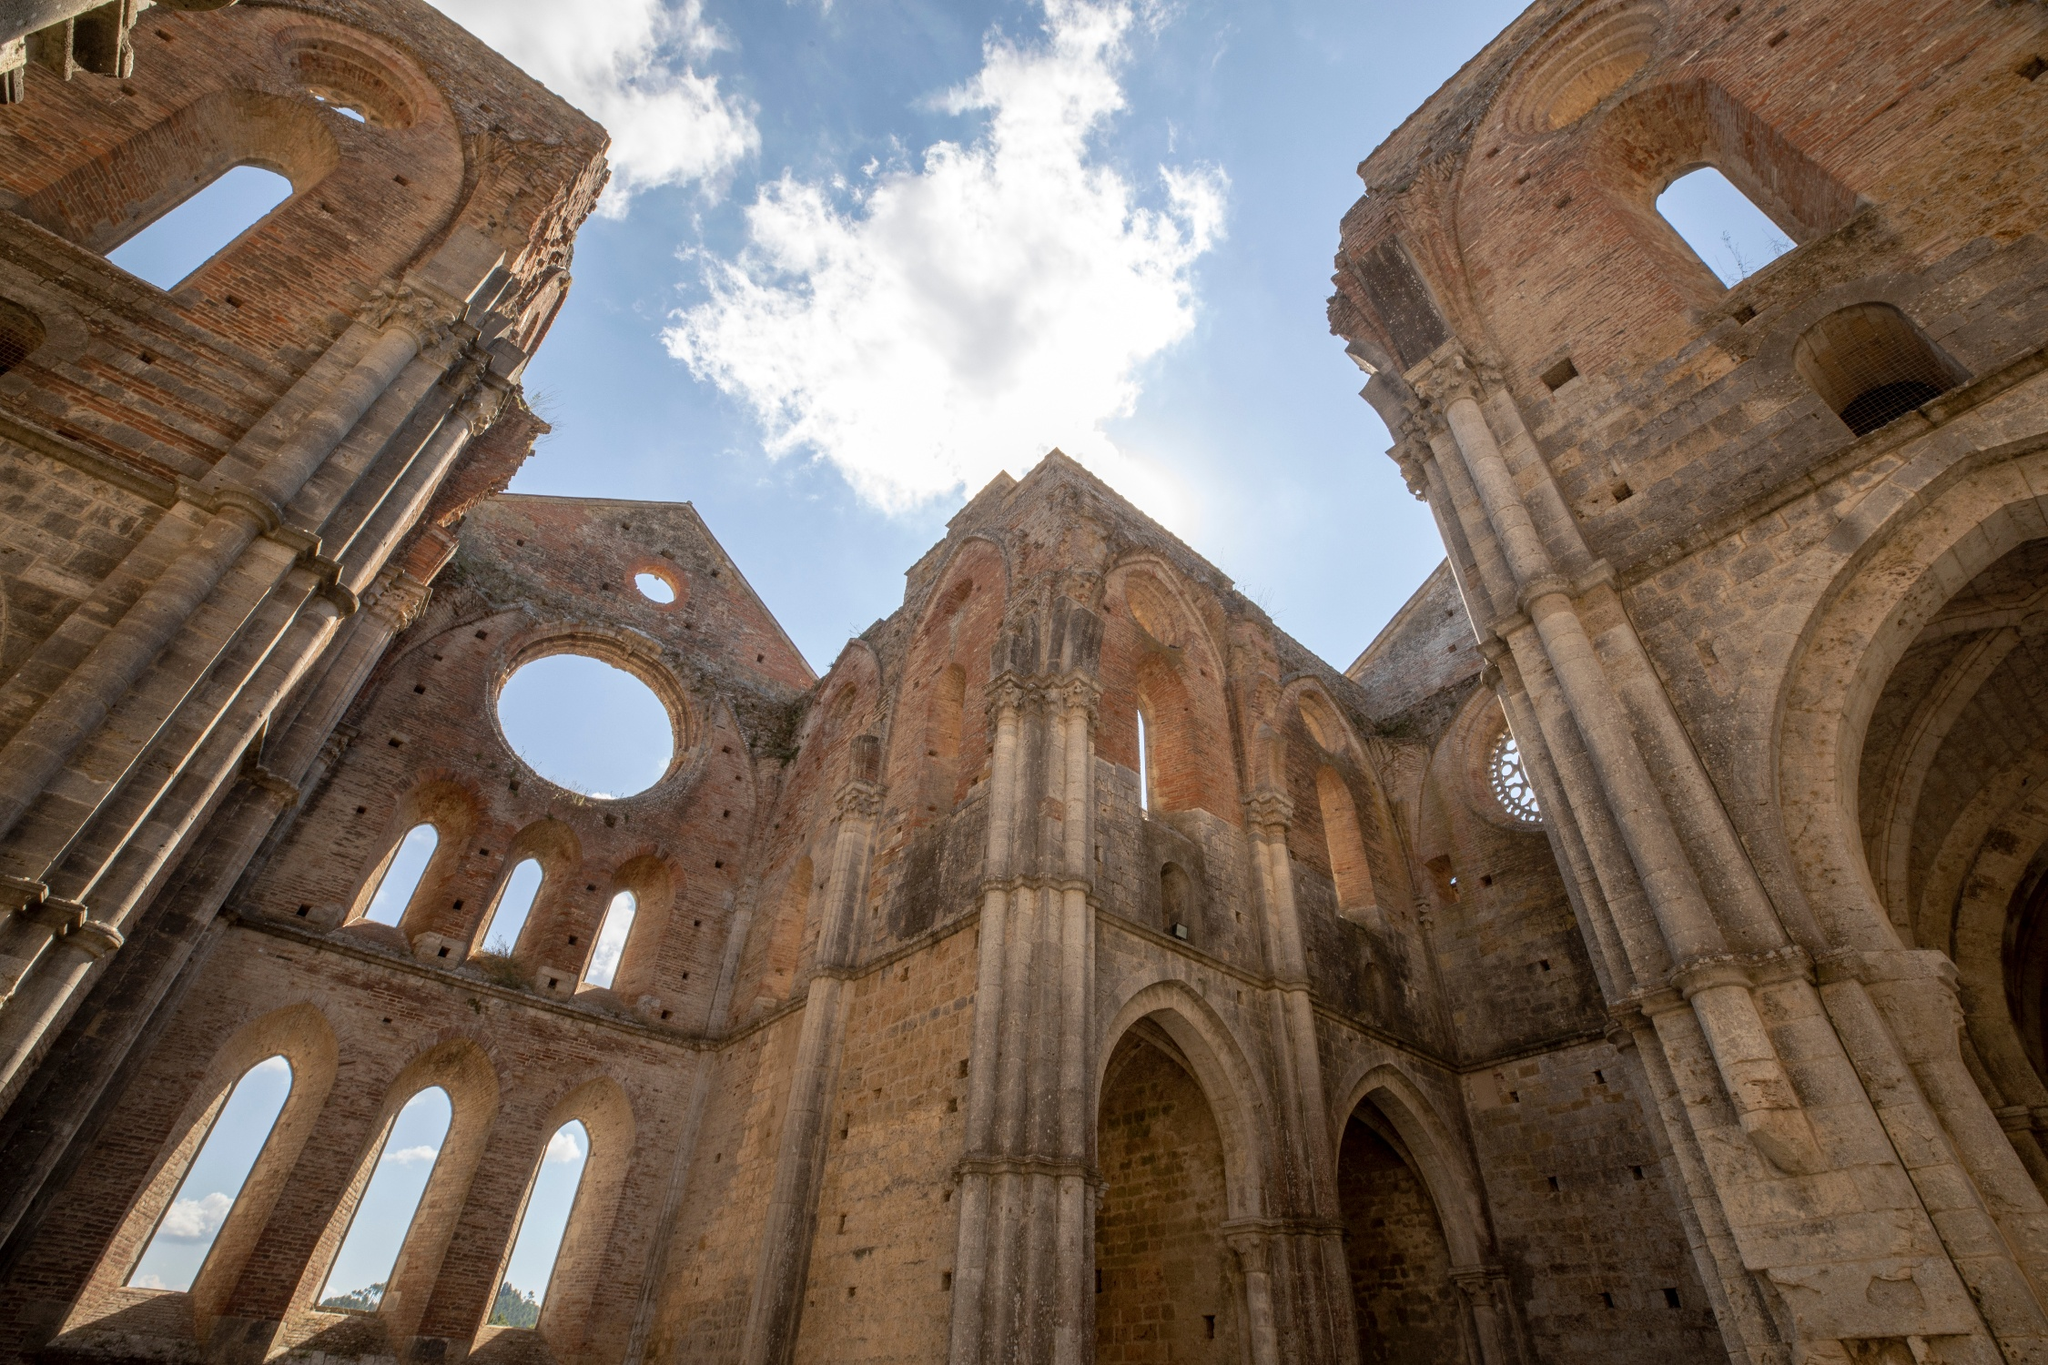Explain the visual content of the image in great detail. The image presents the striking ruins of what appears to be a historic church or cathedral, standing resiliently against a vivid blue sky adorned with scattered, fluffy white clouds. The remnants of this once-stately structure include towering arches and imposing columns, primarily constructed from weathered brick and stone. These ancient architectural elements display considerable signs of degradation; some have large, gaping holes, while others exhibit noticeable chunks and pieces that have crumbled away over time.

Photographed from a low, upward-facing perspective, the image emphasizes the grandiosity of the ruins, giving viewers a sense of immersion and scale. The sunlight gently illuminates parts of the edifice, casting intricate shadows that enhance the texture and depth of the scene. In this tranquil, open space—likely the expansive interior of the historic building—the ruins exude a quiet dignity, suggestive of their richly storied past. The photograph does not feature any recognizable text, discrete objects, or human activity, focusing solely on the serene and dramatic interplay between these stately ruins and the natural environment. 